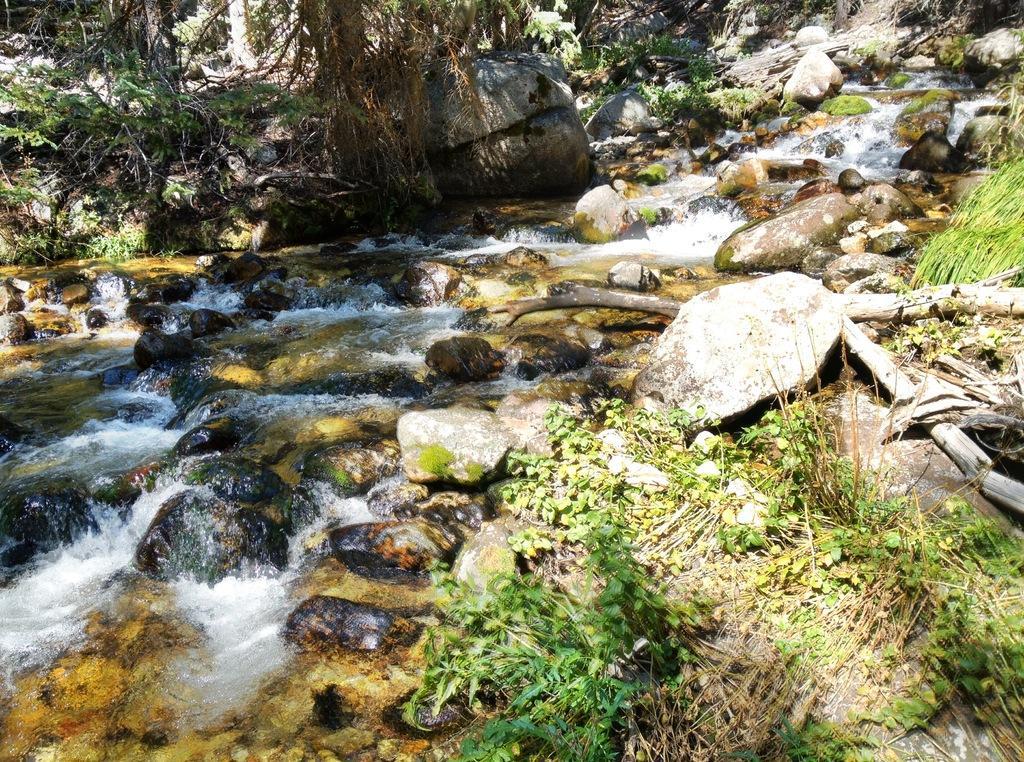Could you give a brief overview of what you see in this image? In this image I can see the water, few stones. In the background I can see few trees in green color. 